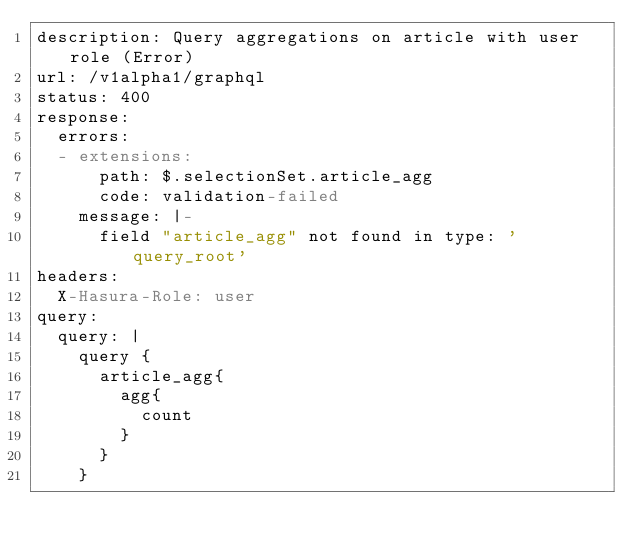Convert code to text. <code><loc_0><loc_0><loc_500><loc_500><_YAML_>description: Query aggregations on article with user role (Error)
url: /v1alpha1/graphql
status: 400
response:
  errors:
  - extensions:
      path: $.selectionSet.article_agg
      code: validation-failed
    message: |-
      field "article_agg" not found in type: 'query_root'
headers:
  X-Hasura-Role: user
query:
  query: |
    query {
      article_agg{
        agg{
          count
        }
      }
    }
</code> 